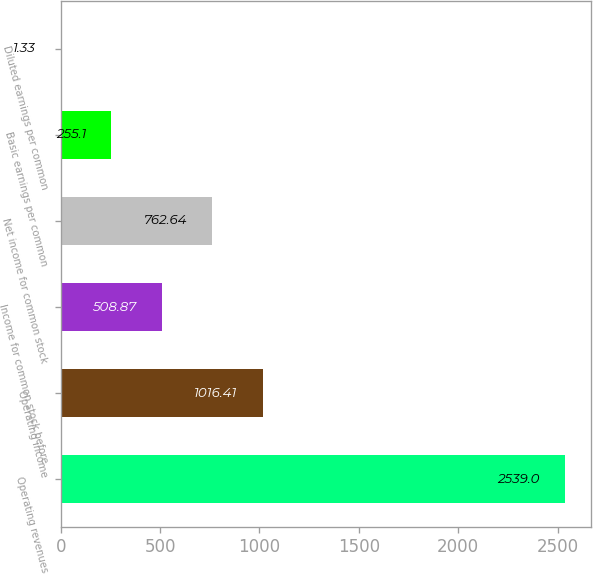Convert chart. <chart><loc_0><loc_0><loc_500><loc_500><bar_chart><fcel>Operating revenues<fcel>Operating income<fcel>Income for common stock before<fcel>Net income for common stock<fcel>Basic earnings per common<fcel>Diluted earnings per common<nl><fcel>2539<fcel>1016.41<fcel>508.87<fcel>762.64<fcel>255.1<fcel>1.33<nl></chart> 